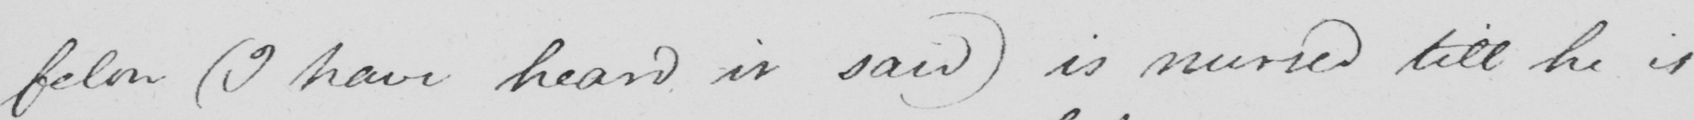Transcribe the text shown in this historical manuscript line. felon  ( I have heard it said )  is nursed till he is 